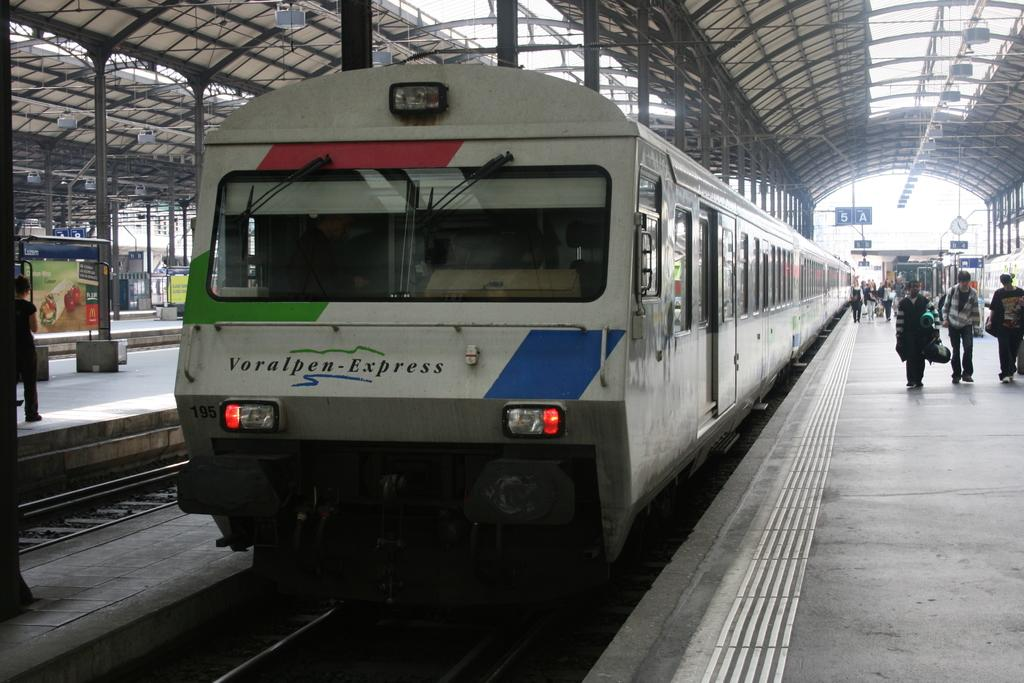<image>
Relay a brief, clear account of the picture shown. A blue, red and white train with 195 and voralpen express on front. 